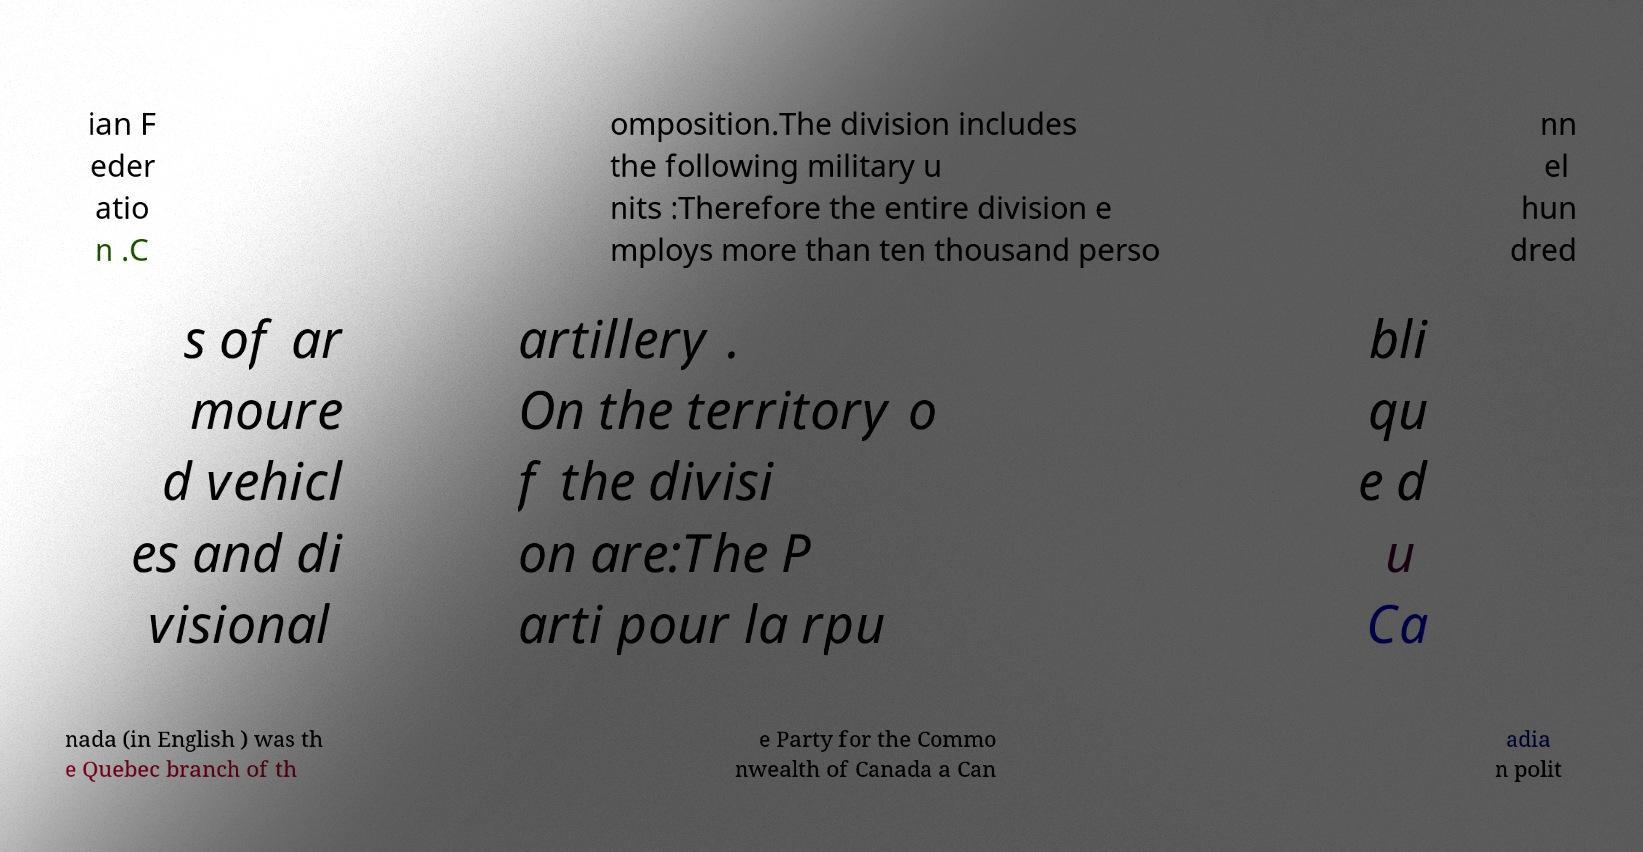Could you extract and type out the text from this image? ian F eder atio n .C omposition.The division includes the following military u nits :Therefore the entire division e mploys more than ten thousand perso nn el hun dred s of ar moure d vehicl es and di visional artillery . On the territory o f the divisi on are:The P arti pour la rpu bli qu e d u Ca nada (in English ) was th e Quebec branch of th e Party for the Commo nwealth of Canada a Can adia n polit 